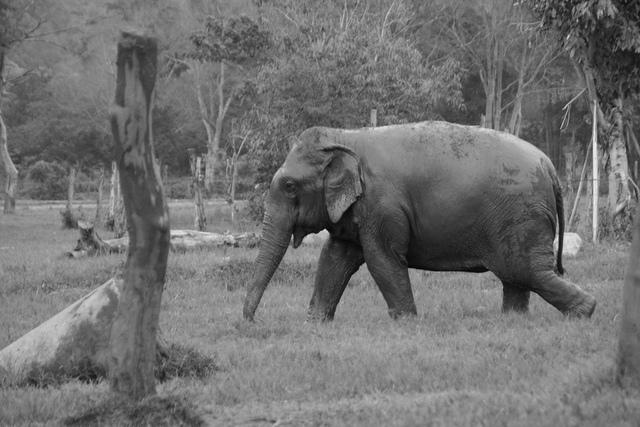Are there other animals near this elephant?
Answer briefly. No. Does this elephant have tusks?
Answer briefly. No. Is the tree stump taller that the elephant?
Be succinct. Yes. Is the animal balancing?
Be succinct. No. How many chopped tree trunks are shown in front of the elephant?
Give a very brief answer. 1. Is there any grass around?
Answer briefly. Yes. Are those pelicans next to the elephant?
Write a very short answer. No. Is he in his natural environment?
Answer briefly. Yes. Where is the elephant looking?
Answer briefly. Ahead. How many tusks does the elephant have?
Give a very brief answer. 0. Are these animals caged?
Answer briefly. No. How many elephants are there?
Concise answer only. 1. Do the elephants look friendly?
Quick response, please. No. What is the elephant doing?
Quick response, please. Walking. Is the elephant moving?
Concise answer only. Yes. Is this elephant wild?
Quick response, please. Yes. Which elephant has tusks?
Short answer required. 0. What kind of animal is this?
Quick response, please. Elephant. Is the elephant plowing?
Concise answer only. No. 